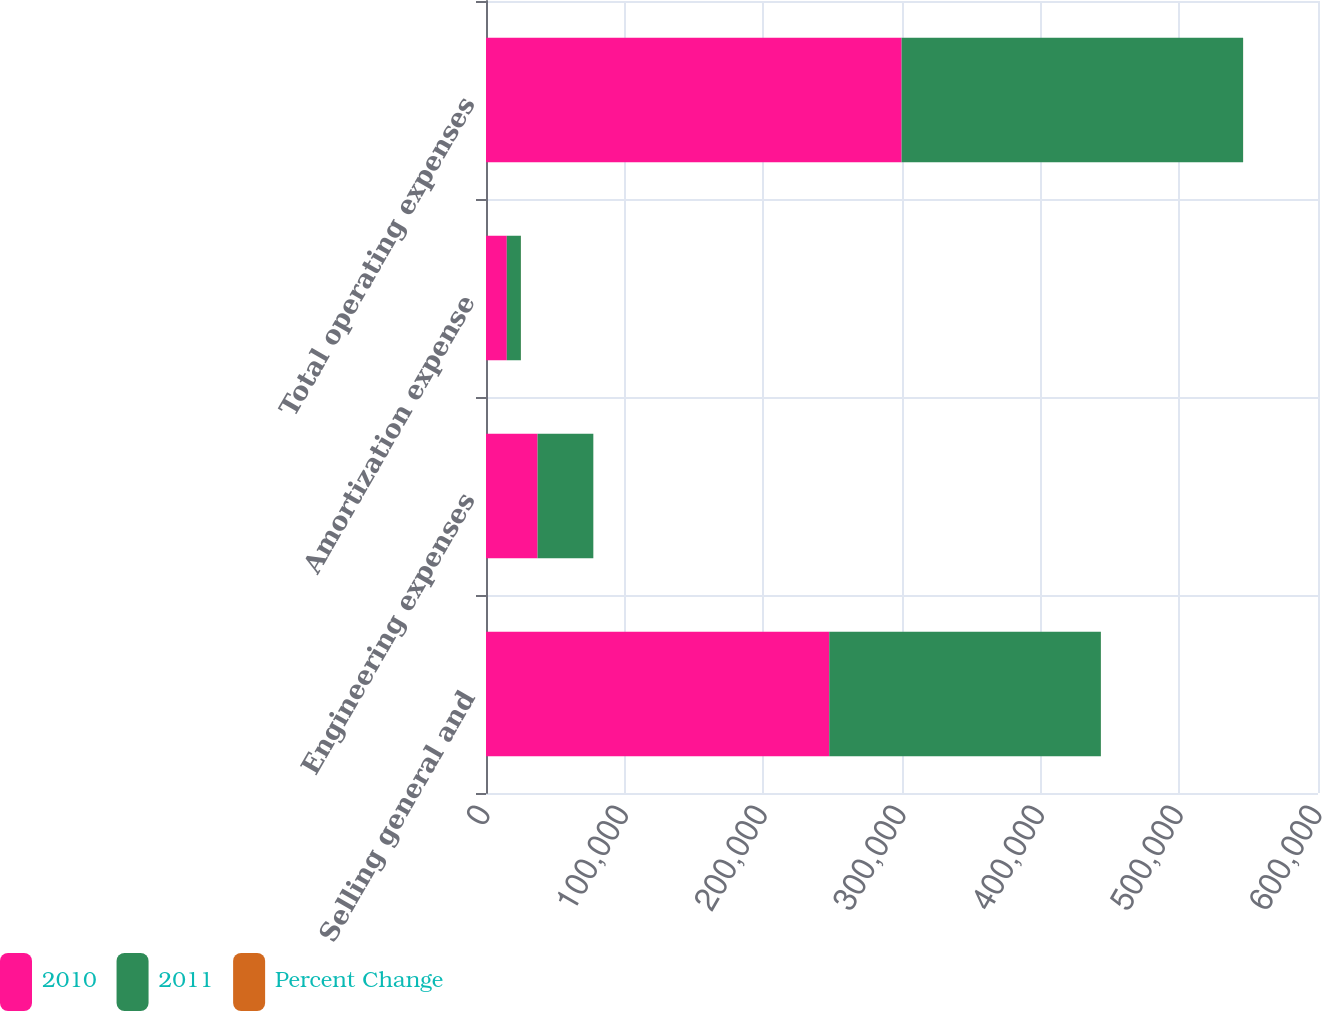Convert chart to OTSL. <chart><loc_0><loc_0><loc_500><loc_500><stacked_bar_chart><ecel><fcel>Selling general and<fcel>Engineering expenses<fcel>Amortization expense<fcel>Total operating expenses<nl><fcel>2010<fcel>247534<fcel>37193<fcel>14996<fcel>299723<nl><fcel>2011<fcel>195892<fcel>40203<fcel>10173<fcel>246268<nl><fcel>Percent Change<fcel>26.4<fcel>7.5<fcel>47.4<fcel>21.7<nl></chart> 